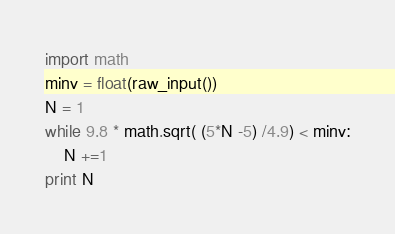Convert code to text. <code><loc_0><loc_0><loc_500><loc_500><_Python_>import math
minv = float(raw_input())
N = 1
while 9.8 * math.sqrt( (5*N -5) /4.9) < minv:
    N +=1
print N</code> 